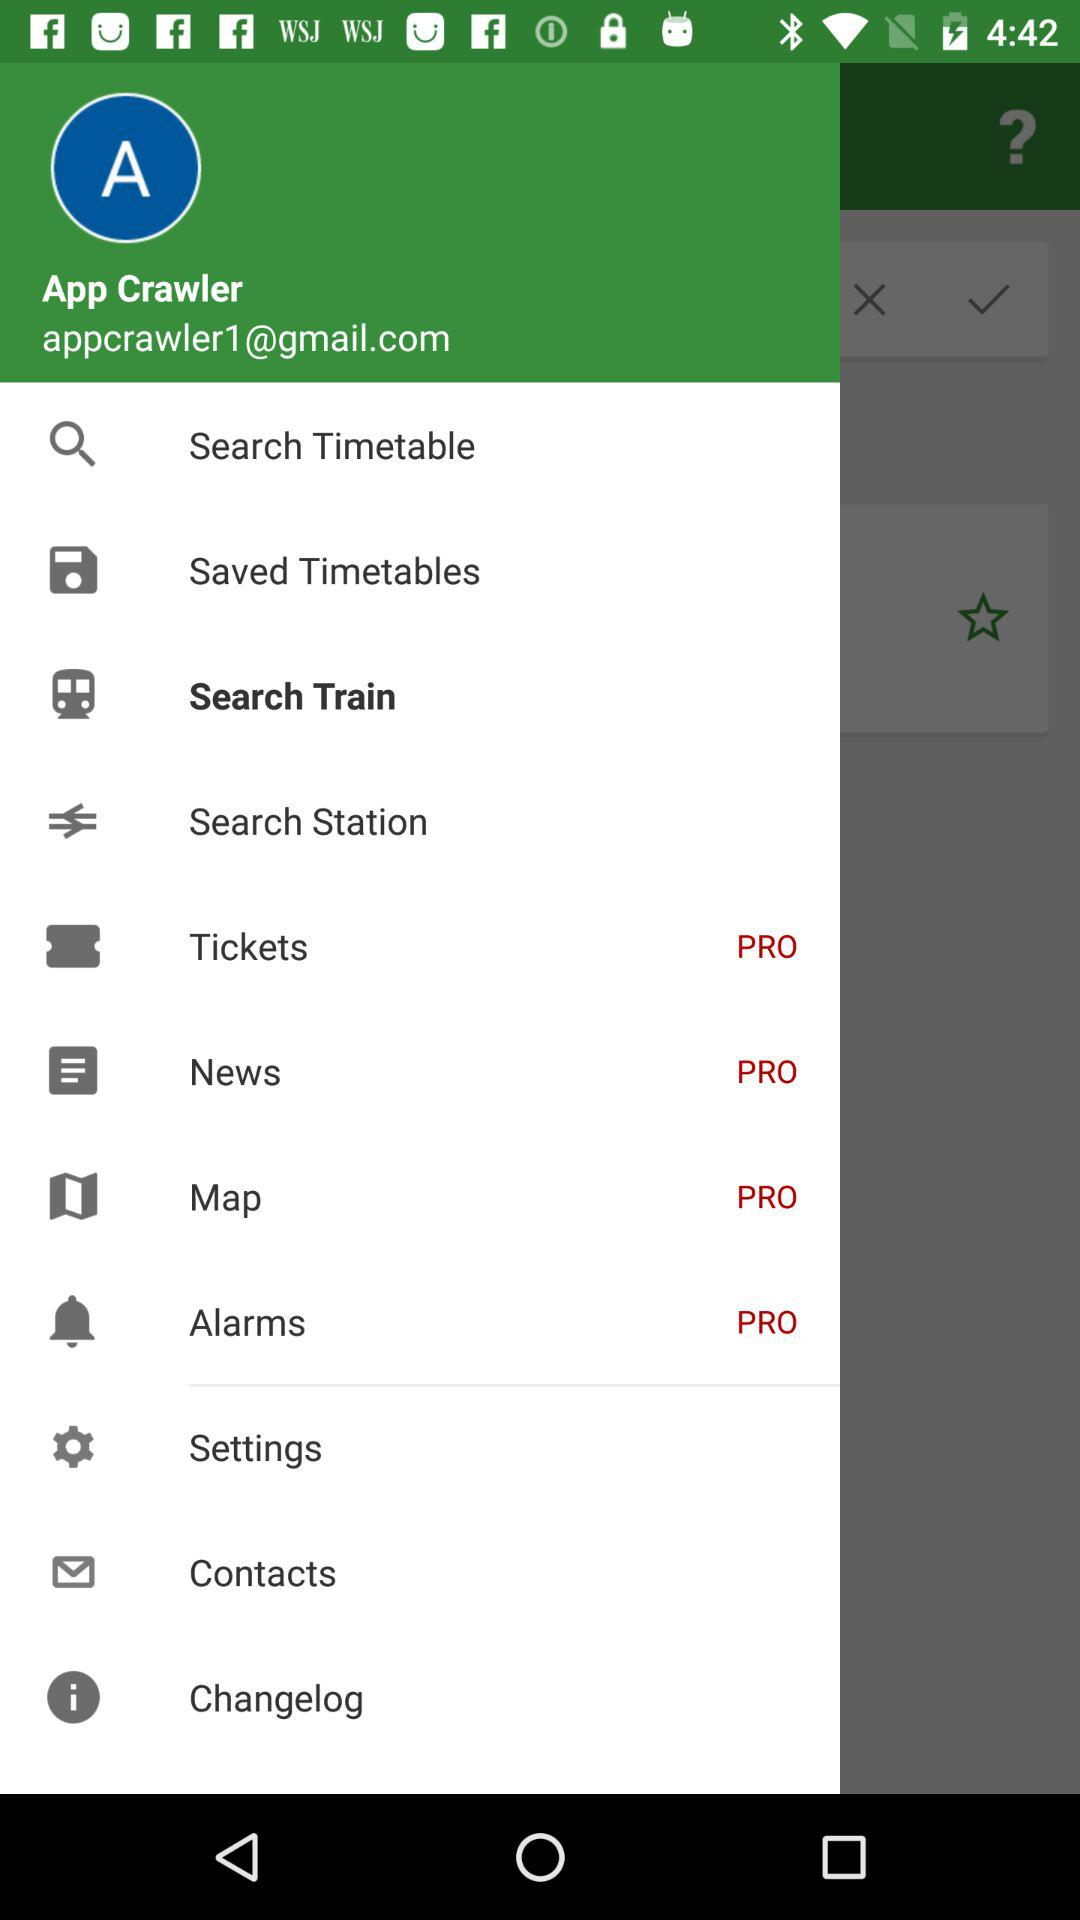What is the name shown on the app? The name shown on the app is App Crawler. 